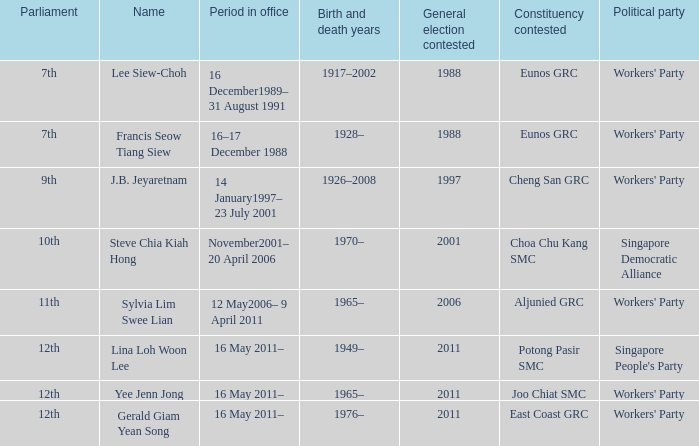Which parliament is sylvia lim swee lian? 11th. 